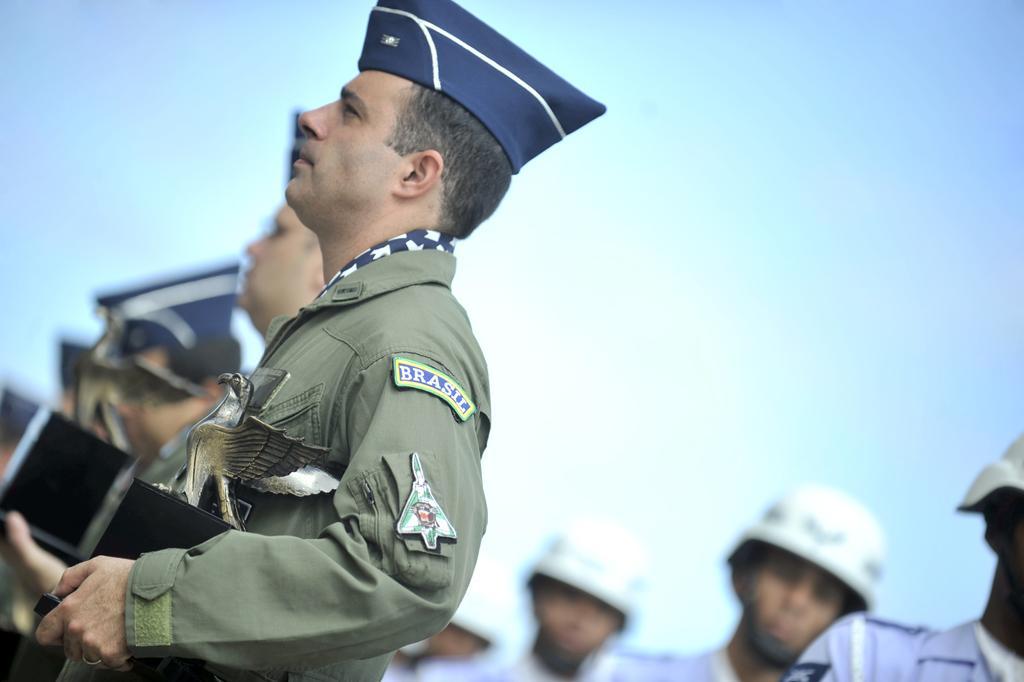Can you describe this image briefly? On the left side, there is a person in a uniform, holding a memento, wearing a violet color helmet and standing. On the right side, there are persons in uniforms, wearing white color helmets and standing. In the background, there are other persons and there are clouds in the sky. 